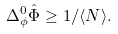<formula> <loc_0><loc_0><loc_500><loc_500>\Delta ^ { 0 } _ { \phi } \hat { \Phi } \geq 1 / \langle N \rangle .</formula> 